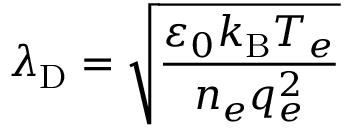<formula> <loc_0><loc_0><loc_500><loc_500>\lambda _ { D } = { \sqrt { \frac { \varepsilon _ { 0 } k _ { B } T _ { e } } { n _ { e } q _ { e } ^ { 2 } } } }</formula> 